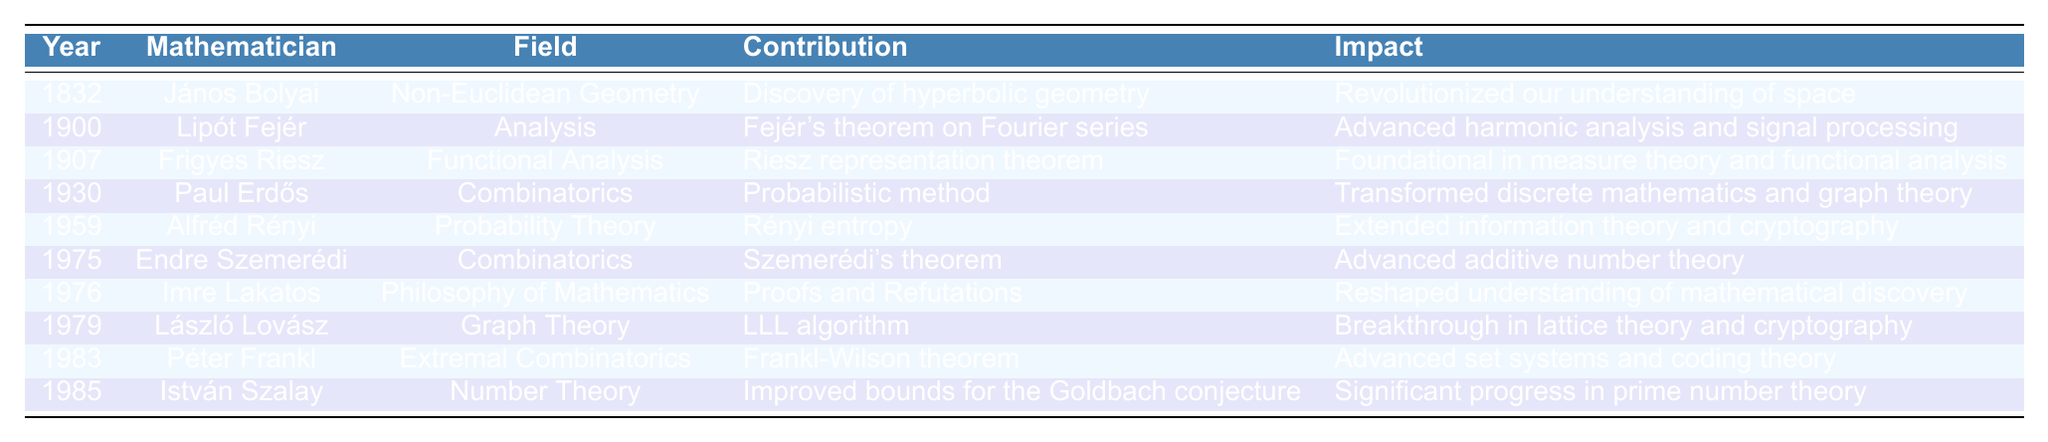What was János Bolyai's major contribution? According to the table, János Bolyai made the contribution of "Discovery of hyperbolic geometry" in the field of "Non-Euclidean Geometry."
Answer: Discovery of hyperbolic geometry Who contributed to Functional Analysis in 1907? The table indicates that Frigyes Riesz contributed to Functional Analysis in the year 1907.
Answer: Frigyes Riesz What is the impact of Alfréd Rényi's contribution? Alfréd Rényi's contribution of "Rényi entropy" in 1959 had an impact of "Extended information theory and cryptography."
Answer: Extended information theory and cryptography How many mathematicians contributed to Combinatorics? The table shows that two mathematicians, Paul Erdős (1930) and Endre Szemerédi (1975), made contributions to Combinatorics, indicating a total count of 2.
Answer: 2 Is Lipót Fejér's contribution related to Harmonic Analysis? Yes, the contribution of Lipót Fejér, "Fejér's theorem on Fourier series," is mentioned to have advanced harmonic analysis, thus confirming its relation.
Answer: Yes Which mathematician has the earliest contribution in the table? The first entry in the table indicates that János Bolyai's contribution in 1832 is the earliest noted, making him the first mathematician listed.
Answer: János Bolyai What was the year of István Szalay's contribution? The table lists István Szalay’s contribution in the year 1985, making it the year of his work.
Answer: 1985 What is the average year of contribution of mathematicians listed in the table? To find the average year, sum the years (1832 + 1900 + 1907 + 1930 + 1959 + 1975 + 1976 + 1979 + 1983 + 1985 = 19,075) and divide by the number of contributions (10), resulting in an average year of 1907.5.
Answer: 1907.5 Which contributions were made after 1975? By reviewing the table, the contributions made after 1975 are by László Lovász (1979), Péter Frankl (1983), and István Szalay (1985).
Answer: László Lovász, Péter Frankl, István Szalay What is the relationship between Szemerédi's theorem and additive number theory? The impact of Szemerédi's theorem is described in the table as "Advanced additive number theory," indicating a direct relationship between his work and the field.
Answer: Direct relationship 